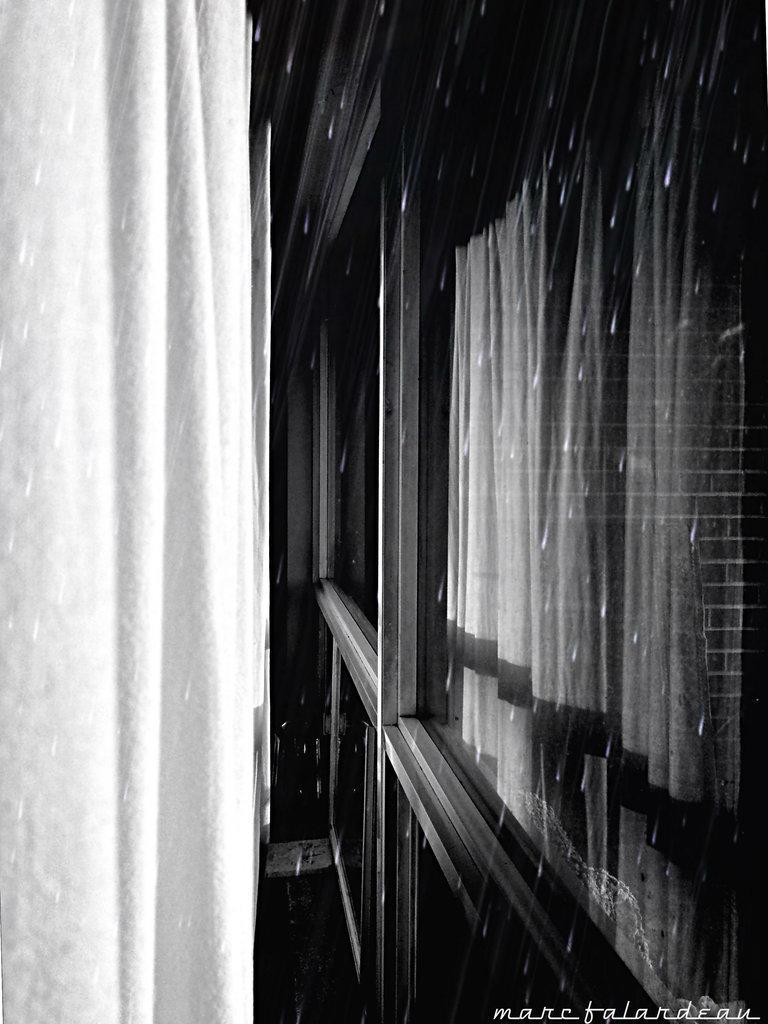Describe this image in one or two sentences. In the picture we can see a window with a glass and inside it we can see a curtain and outside it we can see rain drops. 